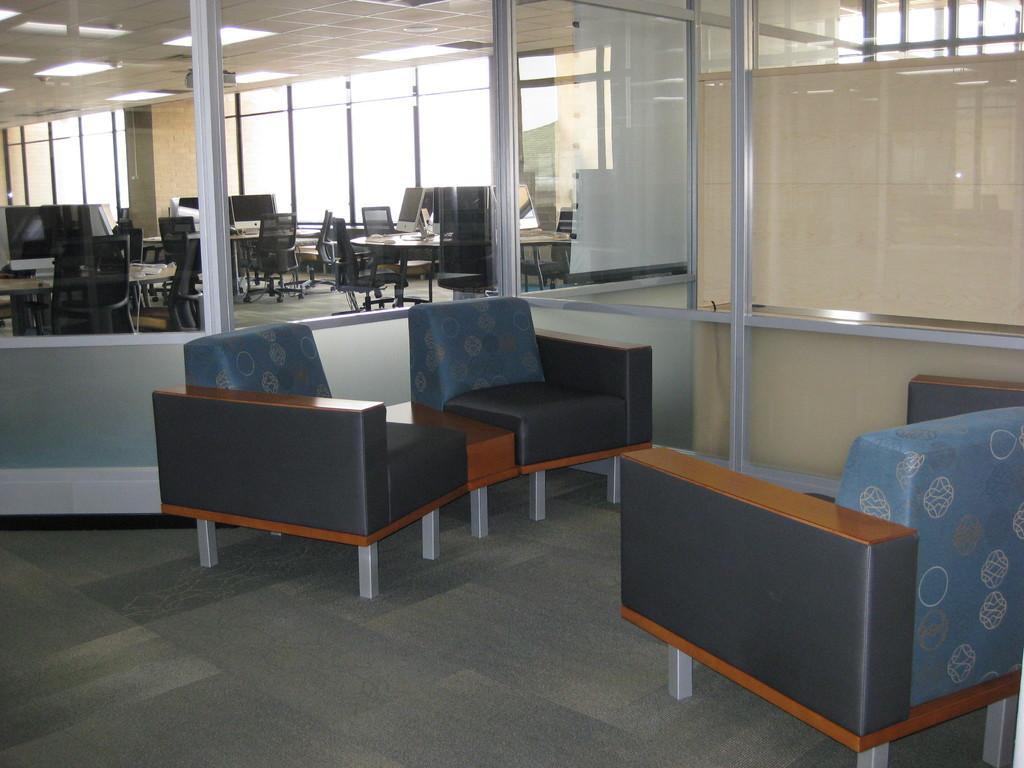Please provide a concise description of this image. This is the picture taken in a office, there are chairs and tables on the floor. Background of the chair is a glass window. 